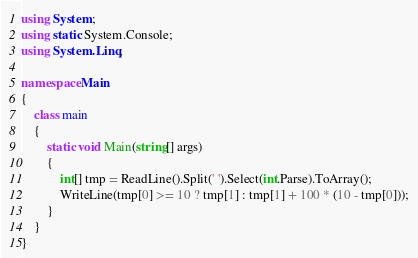Convert code to text. <code><loc_0><loc_0><loc_500><loc_500><_C#_>using System;
using static System.Console;
using System.Linq;

namespace Main
{
    class main
    {
        static void Main(string[] args)
        {
            int[] tmp = ReadLine().Split(' ').Select(int.Parse).ToArray();
            WriteLine(tmp[0] >= 10 ? tmp[1] : tmp[1] + 100 * (10 - tmp[0]));
        }
    }
}</code> 